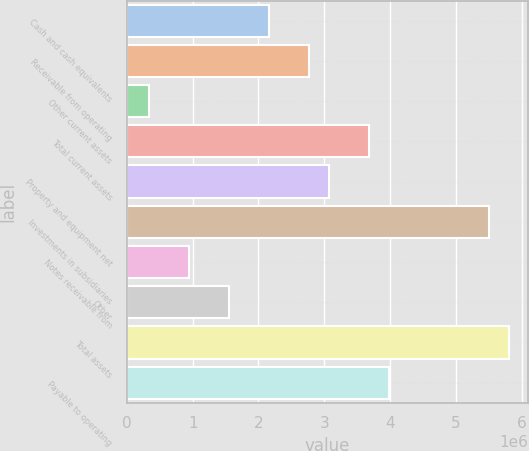Convert chart. <chart><loc_0><loc_0><loc_500><loc_500><bar_chart><fcel>Cash and cash equivalents<fcel>Receivable from operating<fcel>Other current assets<fcel>Total current assets<fcel>Property and equipment net<fcel>Investments in subsidiaries<fcel>Notes receivable from<fcel>Other<fcel>Total assets<fcel>Payable to operating<nl><fcel>2.15726e+06<fcel>2.76547e+06<fcel>332657<fcel>3.67777e+06<fcel>3.06957e+06<fcel>5.50238e+06<fcel>940860<fcel>1.54906e+06<fcel>5.80648e+06<fcel>3.98187e+06<nl></chart> 